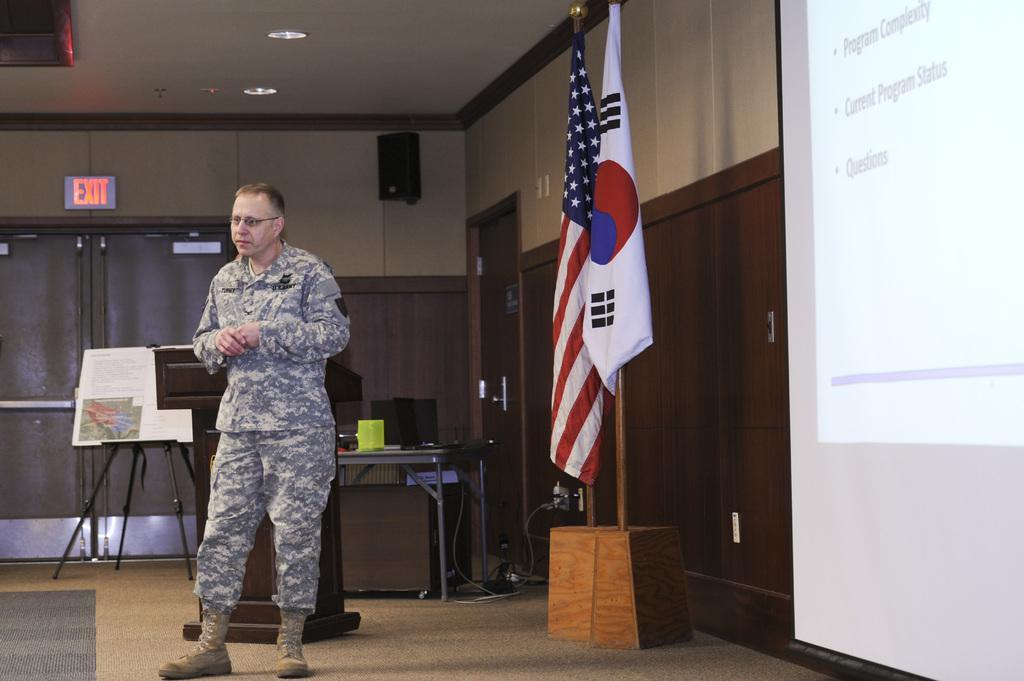Please provide a concise description of this image. In this image in the center there is a person standing. On the right side there are flags and there is a screen, on the screen there is some text displaying on it. In the background there is a wall, there is a board with some text written on it, there is a table, there is a podium and on the table there are objects, there are wires on the ground. At the top on the wall there is a speaker and there are doors and there are lights at the top. 